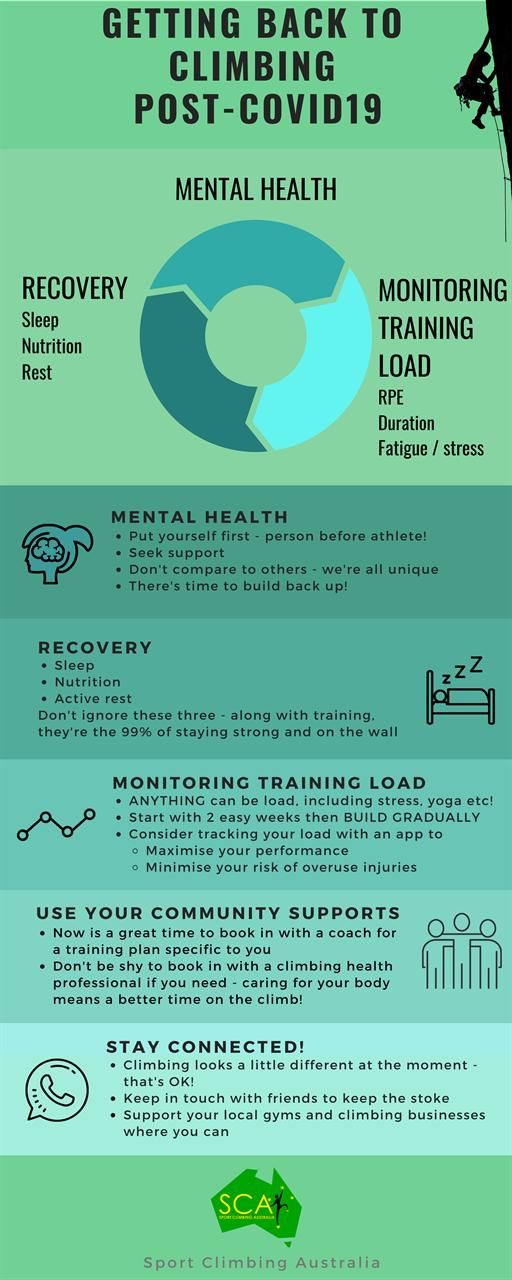Highlight a few significant elements in this photo. There are four tips mentioned for improving mental health. Sleep, nutrition, and active rest are essential factors for promoting recovery. The points mentioned under Monitor Training Load are 3. The second tip mentioned under mental health is to seek support, which involves reaching out to friends, family, or mental health professionals for assistance and guidance. 